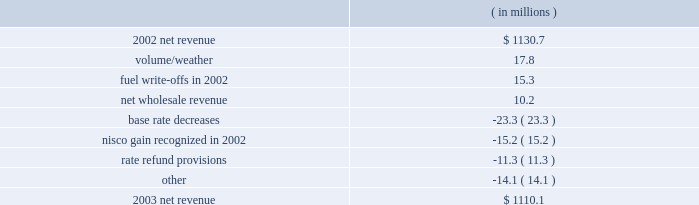Entergy gulf states , inc .
Management's financial discussion and analysis .
The volume/weather variance was due to higher electric sales volume in the service territory .
Billed usage increased a total of 517 gwh in the residential and commercial sectors .
The increase was partially offset by a decrease in industrial usage of 470 gwh due to the loss of two large industrial customers to cogeneration .
The customers accounted for approximately 1% ( 1 % ) of entergy gulf states' net revenue in 2002 .
In 2002 , deferred fuel costs of $ 8.9 million related to a texas fuel reconciliation case were written off and $ 6.5 million in expense resulted from an adjustment in the deregulated asset plan percentage as the result of a power uprate at river bend .
The increase in net wholesale revenue was primarily due to an increase in sales volume to municipal and co- op customers and also to affiliated systems related to entergy's generation resource planning .
The base rate decreases were effective june 2002 and january 2003 , both in the louisiana jurisdiction .
The january 2003 base rate decrease of $ 22.1 million had a minimal impact on net income due to a corresponding reduction in nuclear depreciation and decommissioning expenses associated with the change in accounting to reflect an assumed extension of river bend's useful life .
In 2002 , a gain of $ 15.2 million was recognized for the louisiana portion of the 1988 nelson units 1 and 2 sale .
Entergy gulf states received approval from the lpsc to discontinue applying amortization of the gain against recoverable fuel , resulting in the recognition of the deferred gain in income .
Rate refund provisions caused a decrease in net revenue due to additional provisions recorded in 2003 compared to 2002 for potential rate actions and refunds .
Gross operating revenues and fuel and purchased power expenses gross operating revenues increased primarily due to an increase of $ 440.2 million in fuel cost recovery revenues as a result of higher fuel rates in both the louisiana and texas jurisdictions .
Fuel and purchased power expenses increased $ 471.1 million due to an increase in the market prices of natural gas and purchased power .
Other income statement variances 2004 compared to 2003 other operation and maintenance expenses decreased primarily due to : 2022 voluntary severance program accruals of $ 22.5 million in 2003 ; and 2022 a decrease of $ 4.3 million in nuclear material and labor costs due to reduced staff in 2004. .
What is the growth rate in net revenue in 2003 for entergy gulf states , inc.? 
Computations: ((1110.1 - 1130.7) / 1130.7)
Answer: -0.01822. Entergy gulf states , inc .
Management's financial discussion and analysis .
The volume/weather variance was due to higher electric sales volume in the service territory .
Billed usage increased a total of 517 gwh in the residential and commercial sectors .
The increase was partially offset by a decrease in industrial usage of 470 gwh due to the loss of two large industrial customers to cogeneration .
The customers accounted for approximately 1% ( 1 % ) of entergy gulf states' net revenue in 2002 .
In 2002 , deferred fuel costs of $ 8.9 million related to a texas fuel reconciliation case were written off and $ 6.5 million in expense resulted from an adjustment in the deregulated asset plan percentage as the result of a power uprate at river bend .
The increase in net wholesale revenue was primarily due to an increase in sales volume to municipal and co- op customers and also to affiliated systems related to entergy's generation resource planning .
The base rate decreases were effective june 2002 and january 2003 , both in the louisiana jurisdiction .
The january 2003 base rate decrease of $ 22.1 million had a minimal impact on net income due to a corresponding reduction in nuclear depreciation and decommissioning expenses associated with the change in accounting to reflect an assumed extension of river bend's useful life .
In 2002 , a gain of $ 15.2 million was recognized for the louisiana portion of the 1988 nelson units 1 and 2 sale .
Entergy gulf states received approval from the lpsc to discontinue applying amortization of the gain against recoverable fuel , resulting in the recognition of the deferred gain in income .
Rate refund provisions caused a decrease in net revenue due to additional provisions recorded in 2003 compared to 2002 for potential rate actions and refunds .
Gross operating revenues and fuel and purchased power expenses gross operating revenues increased primarily due to an increase of $ 440.2 million in fuel cost recovery revenues as a result of higher fuel rates in both the louisiana and texas jurisdictions .
Fuel and purchased power expenses increased $ 471.1 million due to an increase in the market prices of natural gas and purchased power .
Other income statement variances 2004 compared to 2003 other operation and maintenance expenses decreased primarily due to : 2022 voluntary severance program accruals of $ 22.5 million in 2003 ; and 2022 a decrease of $ 4.3 million in nuclear material and labor costs due to reduced staff in 2004. .
What is the increase in fuel cost recovery revenues as a percentage of the change in net revenue from 2002 to 2003? 
Computations: (440.2 / (1130.7 - 1110.1))
Answer: 21.36893. Entergy gulf states , inc .
Management's financial discussion and analysis .
The volume/weather variance was due to higher electric sales volume in the service territory .
Billed usage increased a total of 517 gwh in the residential and commercial sectors .
The increase was partially offset by a decrease in industrial usage of 470 gwh due to the loss of two large industrial customers to cogeneration .
The customers accounted for approximately 1% ( 1 % ) of entergy gulf states' net revenue in 2002 .
In 2002 , deferred fuel costs of $ 8.9 million related to a texas fuel reconciliation case were written off and $ 6.5 million in expense resulted from an adjustment in the deregulated asset plan percentage as the result of a power uprate at river bend .
The increase in net wholesale revenue was primarily due to an increase in sales volume to municipal and co- op customers and also to affiliated systems related to entergy's generation resource planning .
The base rate decreases were effective june 2002 and january 2003 , both in the louisiana jurisdiction .
The january 2003 base rate decrease of $ 22.1 million had a minimal impact on net income due to a corresponding reduction in nuclear depreciation and decommissioning expenses associated with the change in accounting to reflect an assumed extension of river bend's useful life .
In 2002 , a gain of $ 15.2 million was recognized for the louisiana portion of the 1988 nelson units 1 and 2 sale .
Entergy gulf states received approval from the lpsc to discontinue applying amortization of the gain against recoverable fuel , resulting in the recognition of the deferred gain in income .
Rate refund provisions caused a decrease in net revenue due to additional provisions recorded in 2003 compared to 2002 for potential rate actions and refunds .
Gross operating revenues and fuel and purchased power expenses gross operating revenues increased primarily due to an increase of $ 440.2 million in fuel cost recovery revenues as a result of higher fuel rates in both the louisiana and texas jurisdictions .
Fuel and purchased power expenses increased $ 471.1 million due to an increase in the market prices of natural gas and purchased power .
Other income statement variances 2004 compared to 2003 other operation and maintenance expenses decreased primarily due to : 2022 voluntary severance program accruals of $ 22.5 million in 2003 ; and 2022 a decrease of $ 4.3 million in nuclear material and labor costs due to reduced staff in 2004. .
What is the net change in net revenue during 2003 for entergy gulf states , inc.? 
Computations: (1110.1 - 1130.7)
Answer: -20.6. 